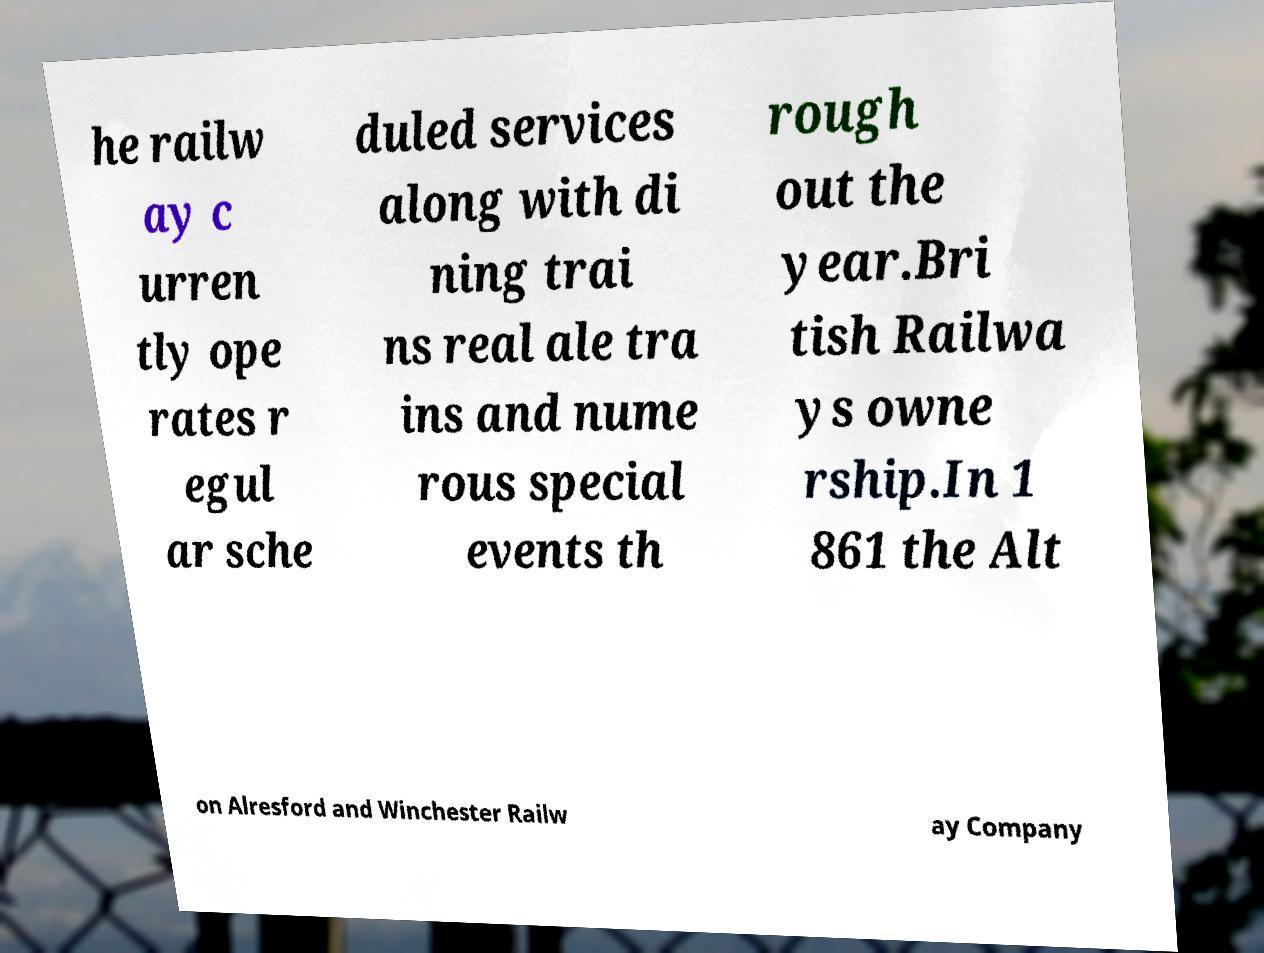Can you accurately transcribe the text from the provided image for me? he railw ay c urren tly ope rates r egul ar sche duled services along with di ning trai ns real ale tra ins and nume rous special events th rough out the year.Bri tish Railwa ys owne rship.In 1 861 the Alt on Alresford and Winchester Railw ay Company 